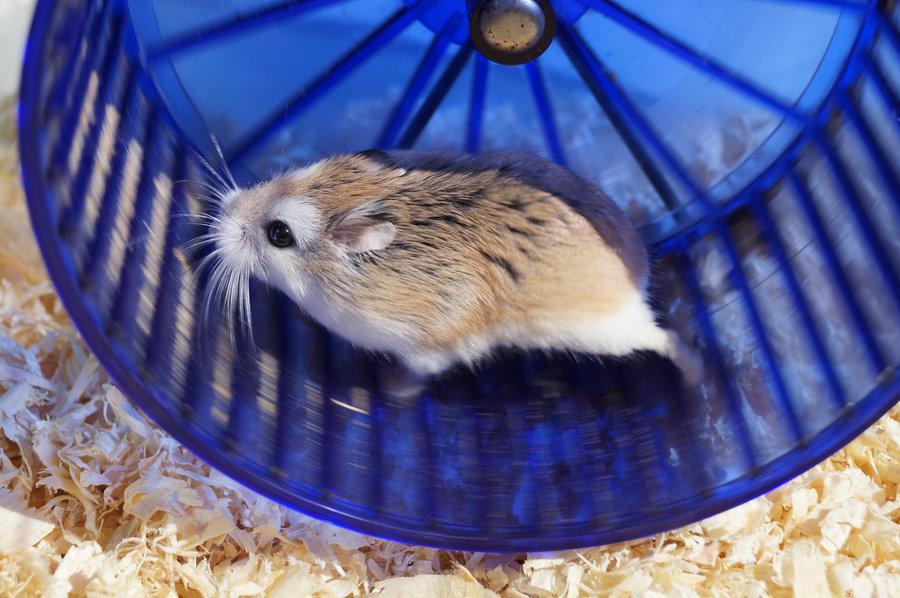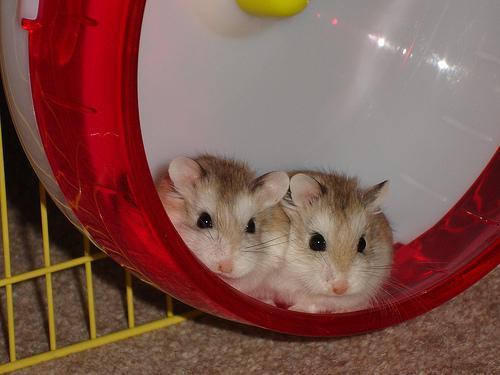The first image is the image on the left, the second image is the image on the right. Considering the images on both sides, is "The left image contains a rodent running on a blue hamster wheel." valid? Answer yes or no. Yes. The first image is the image on the left, the second image is the image on the right. Analyze the images presented: Is the assertion "Each image features at least one pet rodent in a wheel, and the wheel on the left is blue while the one on the right is red." valid? Answer yes or no. Yes. 